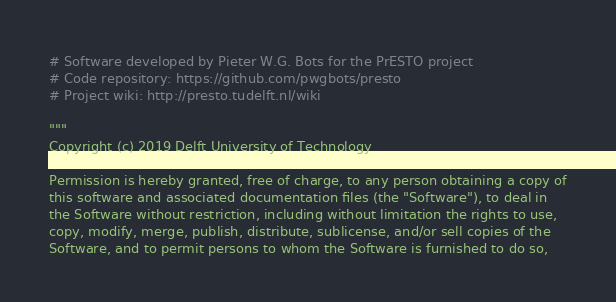<code> <loc_0><loc_0><loc_500><loc_500><_Python_># Software developed by Pieter W.G. Bots for the PrESTO project
# Code repository: https://github.com/pwgbots/presto
# Project wiki: http://presto.tudelft.nl/wiki

"""
Copyright (c) 2019 Delft University of Technology

Permission is hereby granted, free of charge, to any person obtaining a copy of
this software and associated documentation files (the "Software"), to deal in
the Software without restriction, including without limitation the rights to use,
copy, modify, merge, publish, distribute, sublicense, and/or sell copies of the
Software, and to permit persons to whom the Software is furnished to do so,</code> 